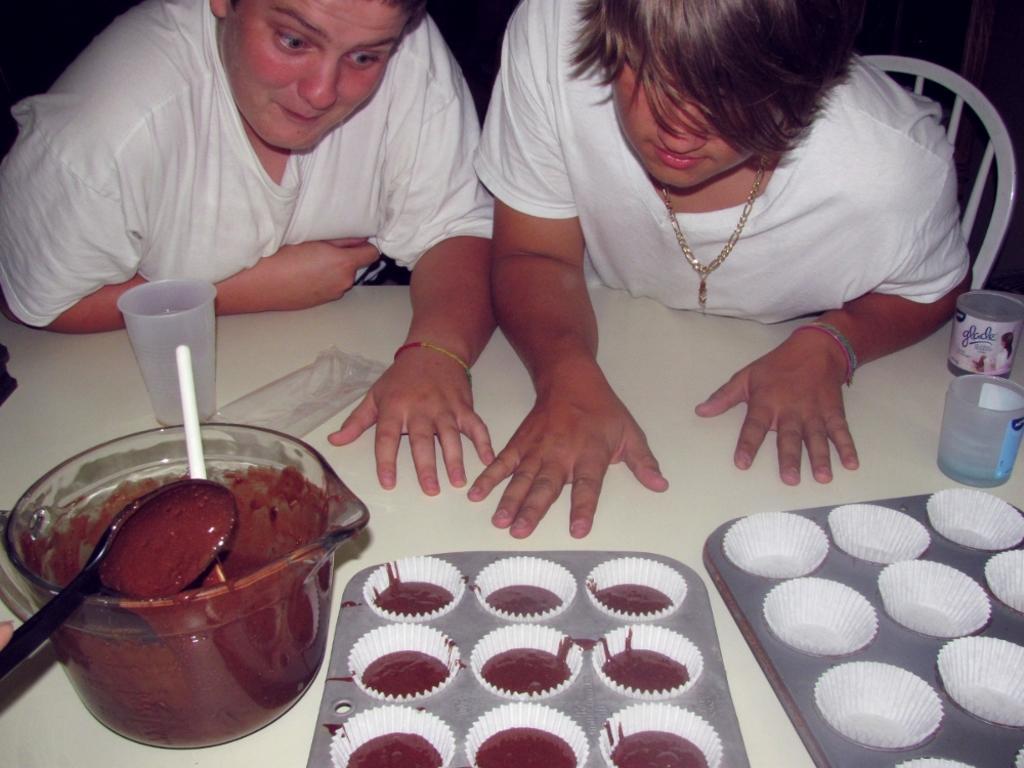In one or two sentences, can you explain what this image depicts? In this image I can see two people are sitting on chairs. I can see trays,bowl,spoon and few objects on the table. 